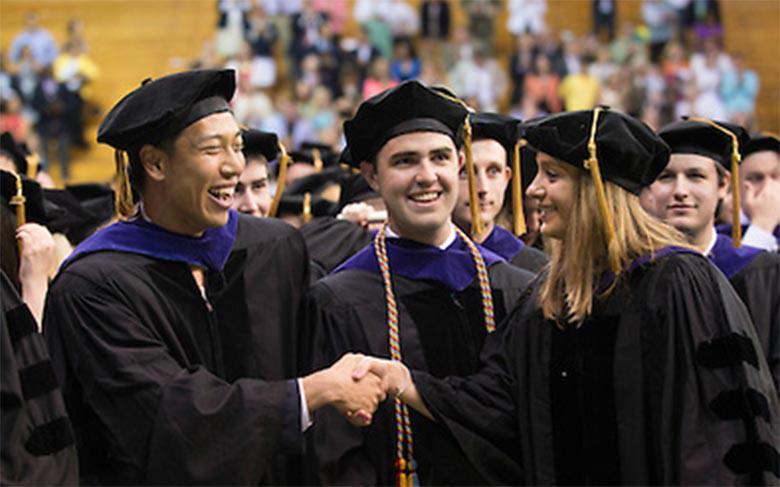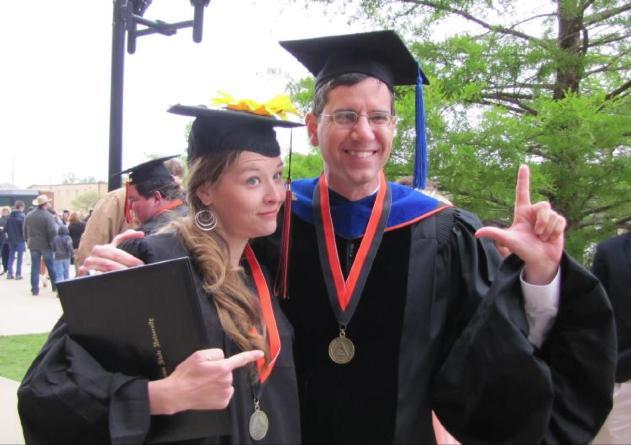The first image is the image on the left, the second image is the image on the right. Given the left and right images, does the statement "An image includes three blond girls in graduation garb, posed side-by-side in a straight row." hold true? Answer yes or no. No. The first image is the image on the left, the second image is the image on the right. Analyze the images presented: Is the assertion "There are only women in the left image, but both men and women on the right." valid? Answer yes or no. No. 